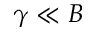<formula> <loc_0><loc_0><loc_500><loc_500>\gamma \ll B</formula> 